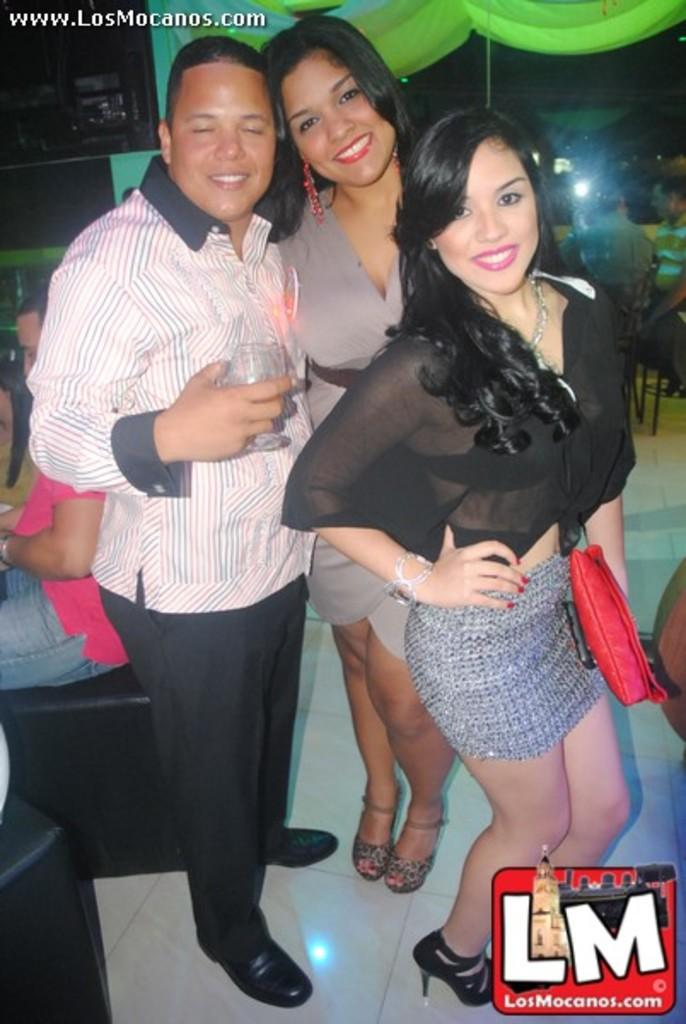How many people are standing in the center of the picture? There are two women and a man standing in the center of the picture. What can be seen on the left side of the image? There are people and couches on the left side of the image. What type of furniture is visible in the background of the image? There are chairs in the background of the image. Can you describe the background of the image? There are people, a light source, and other objects in the background of the image. What type of powder is being used by the goat in the image? There is no goat present in the image, and therefore no powder or related activity can be observed. 